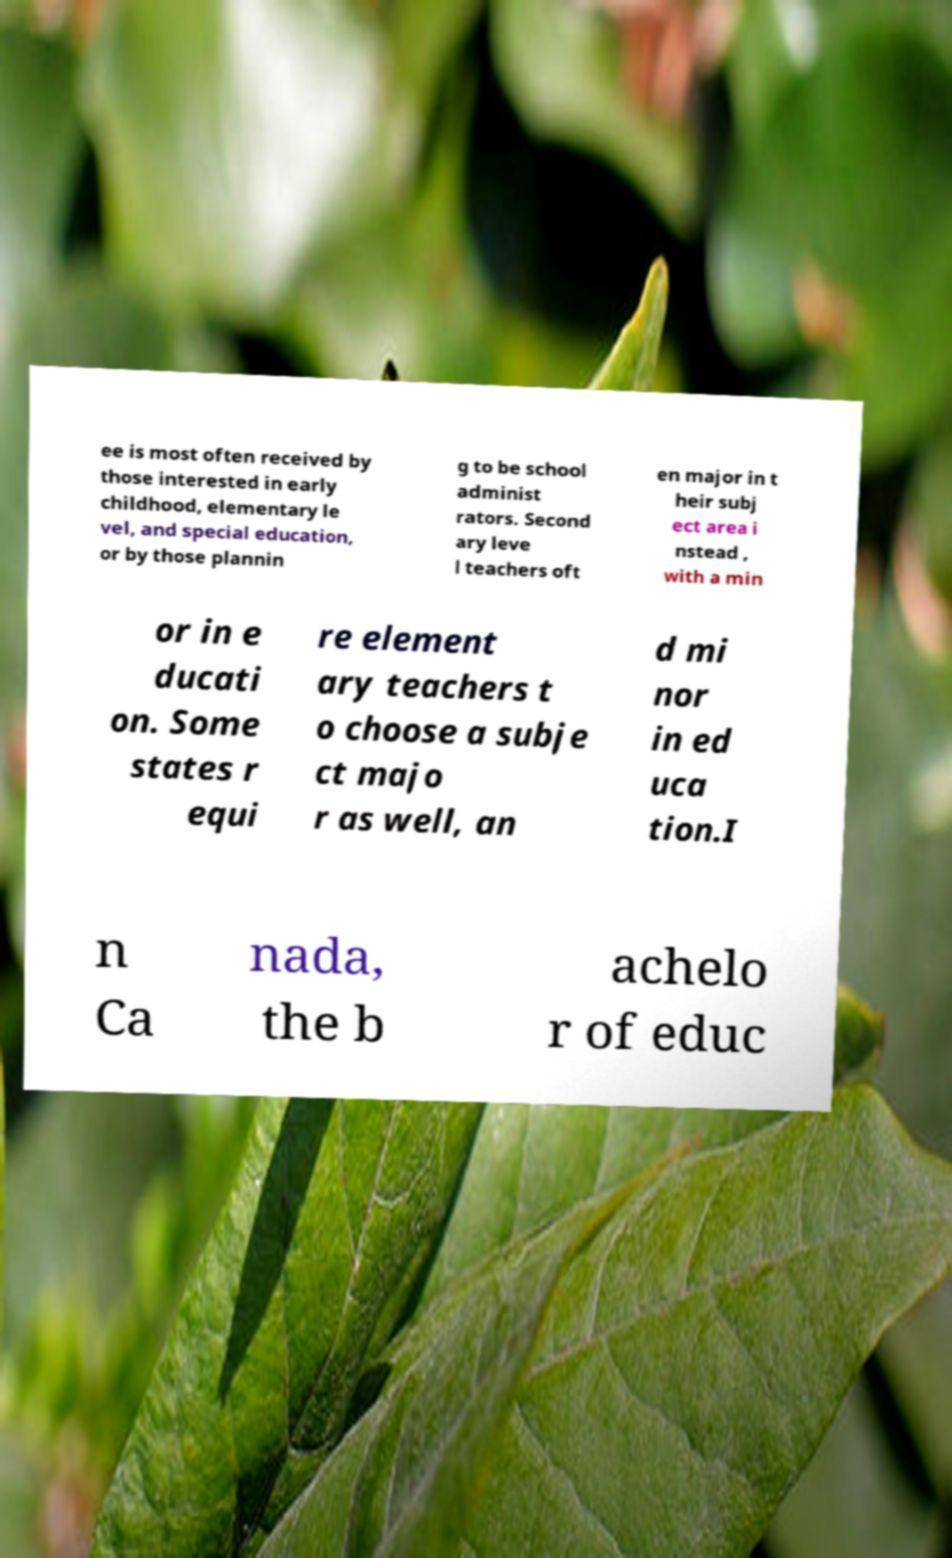What messages or text are displayed in this image? I need them in a readable, typed format. ee is most often received by those interested in early childhood, elementary le vel, and special education, or by those plannin g to be school administ rators. Second ary leve l teachers oft en major in t heir subj ect area i nstead , with a min or in e ducati on. Some states r equi re element ary teachers t o choose a subje ct majo r as well, an d mi nor in ed uca tion.I n Ca nada, the b achelo r of educ 